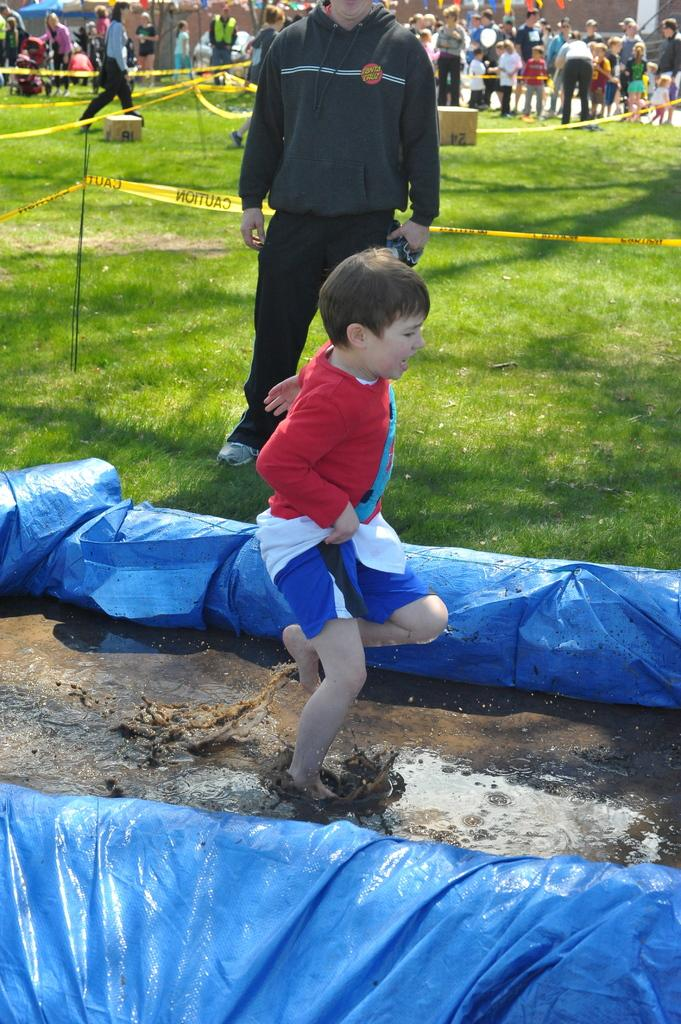Who is the main subject in the image? There is a boy in the image. What is the boy doing in the image? The boy is in motion in the image. What is the boy's location in the image? The boy is in the mud in the image. What type of vegetation can be seen in the image? There is grass visible in the image. How many people are present in the image? There are people in the image. What type of protective covering is present in the image? Plastic covers are present in the image. What other objects can be seen in the image? There are other objects visible in the image. What type of finger food is being served at the feast in the image? There is no feast present in the image, so it is not possible to determine what type of finger food might be served. 